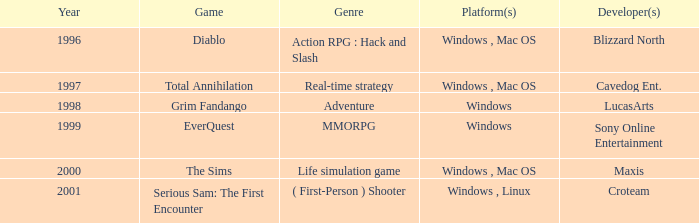Which adventure game is available on the windows platform and was released after 1997? Grim Fandango. 